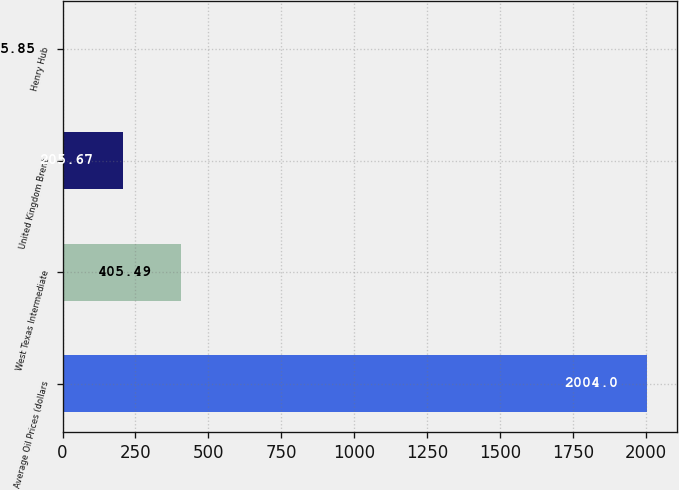Convert chart to OTSL. <chart><loc_0><loc_0><loc_500><loc_500><bar_chart><fcel>Average Oil Prices (dollars<fcel>West Texas Intermediate<fcel>United Kingdom Brent<fcel>Henry Hub<nl><fcel>2004<fcel>405.49<fcel>205.67<fcel>5.85<nl></chart> 